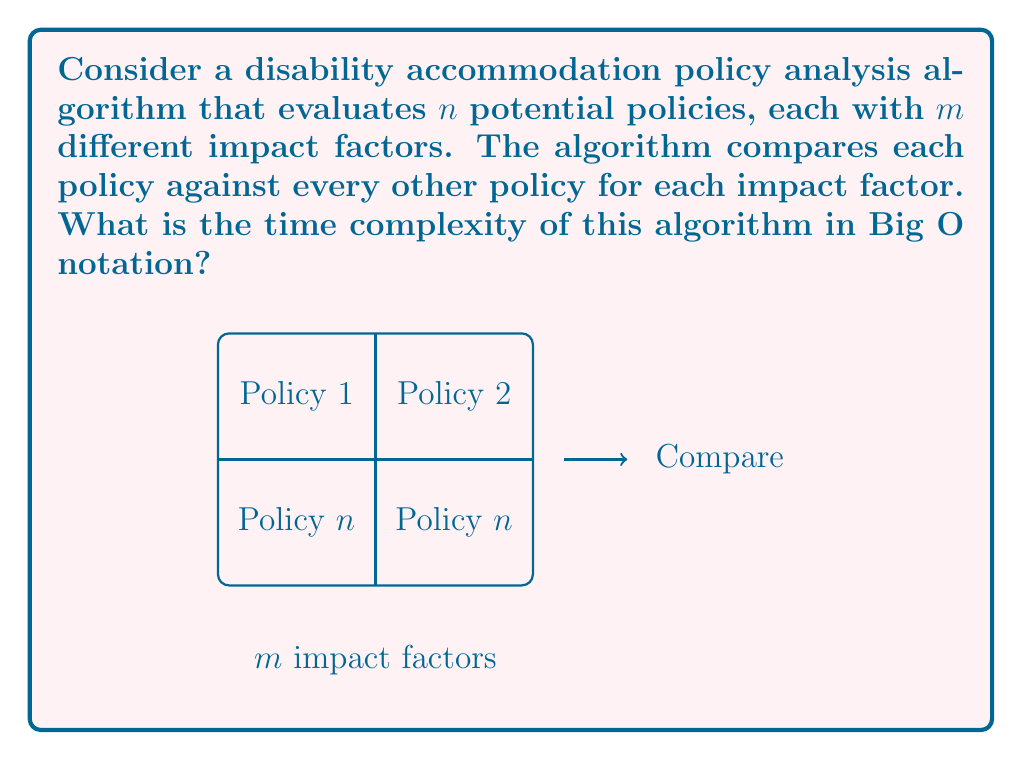What is the answer to this math problem? To solve this problem, let's break down the algorithm's operations:

1. We have $n$ policies to evaluate.
2. Each policy is compared with every other policy, which means we have $\binom{n}{2} = \frac{n(n-1)}{2}$ comparisons.
3. For each comparison, we evaluate $m$ different impact factors.

Therefore, the total number of operations is:

$$\frac{n(n-1)}{2} \cdot m$$

Expanding this:

$$\frac{n^2m - nm}{2}$$

In Big O notation, we focus on the highest order term and ignore constants. The highest order term here is $n^2m$.

Thus, the time complexity of this algorithm is $O(n^2m)$.

It's worth noting that:
- If $m$ is considered a constant (i.e., the number of impact factors doesn't change with the number of policies), the complexity would simplify to $O(n^2)$.
- However, in real-world policy analysis, the number of impact factors might indeed scale with the number of policies, so keeping $m$ in the notation provides a more accurate representation of the algorithm's complexity.
Answer: $O(n^2m)$ 